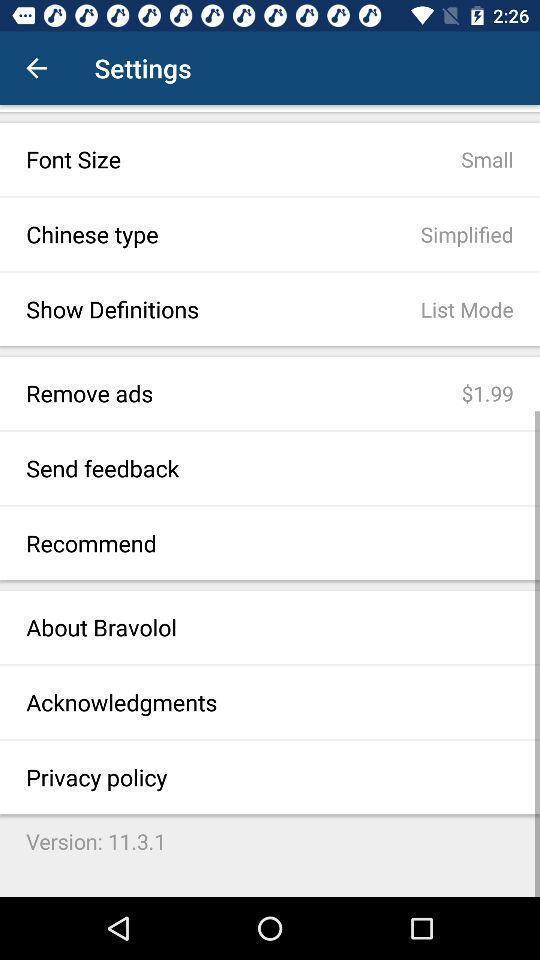Provide a detailed account of this screenshot. Screen displaying multiple options in settings page. 